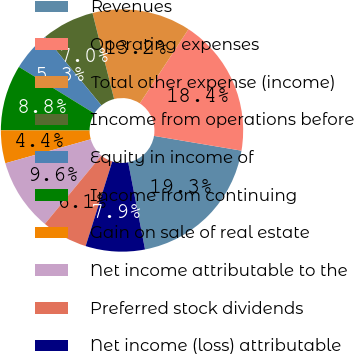Convert chart. <chart><loc_0><loc_0><loc_500><loc_500><pie_chart><fcel>Revenues<fcel>Operating expenses<fcel>Total other expense (income)<fcel>Income from operations before<fcel>Equity in income of<fcel>Income from continuing<fcel>Gain on sale of real estate<fcel>Net income attributable to the<fcel>Preferred stock dividends<fcel>Net income (loss) attributable<nl><fcel>19.3%<fcel>18.42%<fcel>13.16%<fcel>7.02%<fcel>5.26%<fcel>8.77%<fcel>4.39%<fcel>9.65%<fcel>6.14%<fcel>7.89%<nl></chart> 